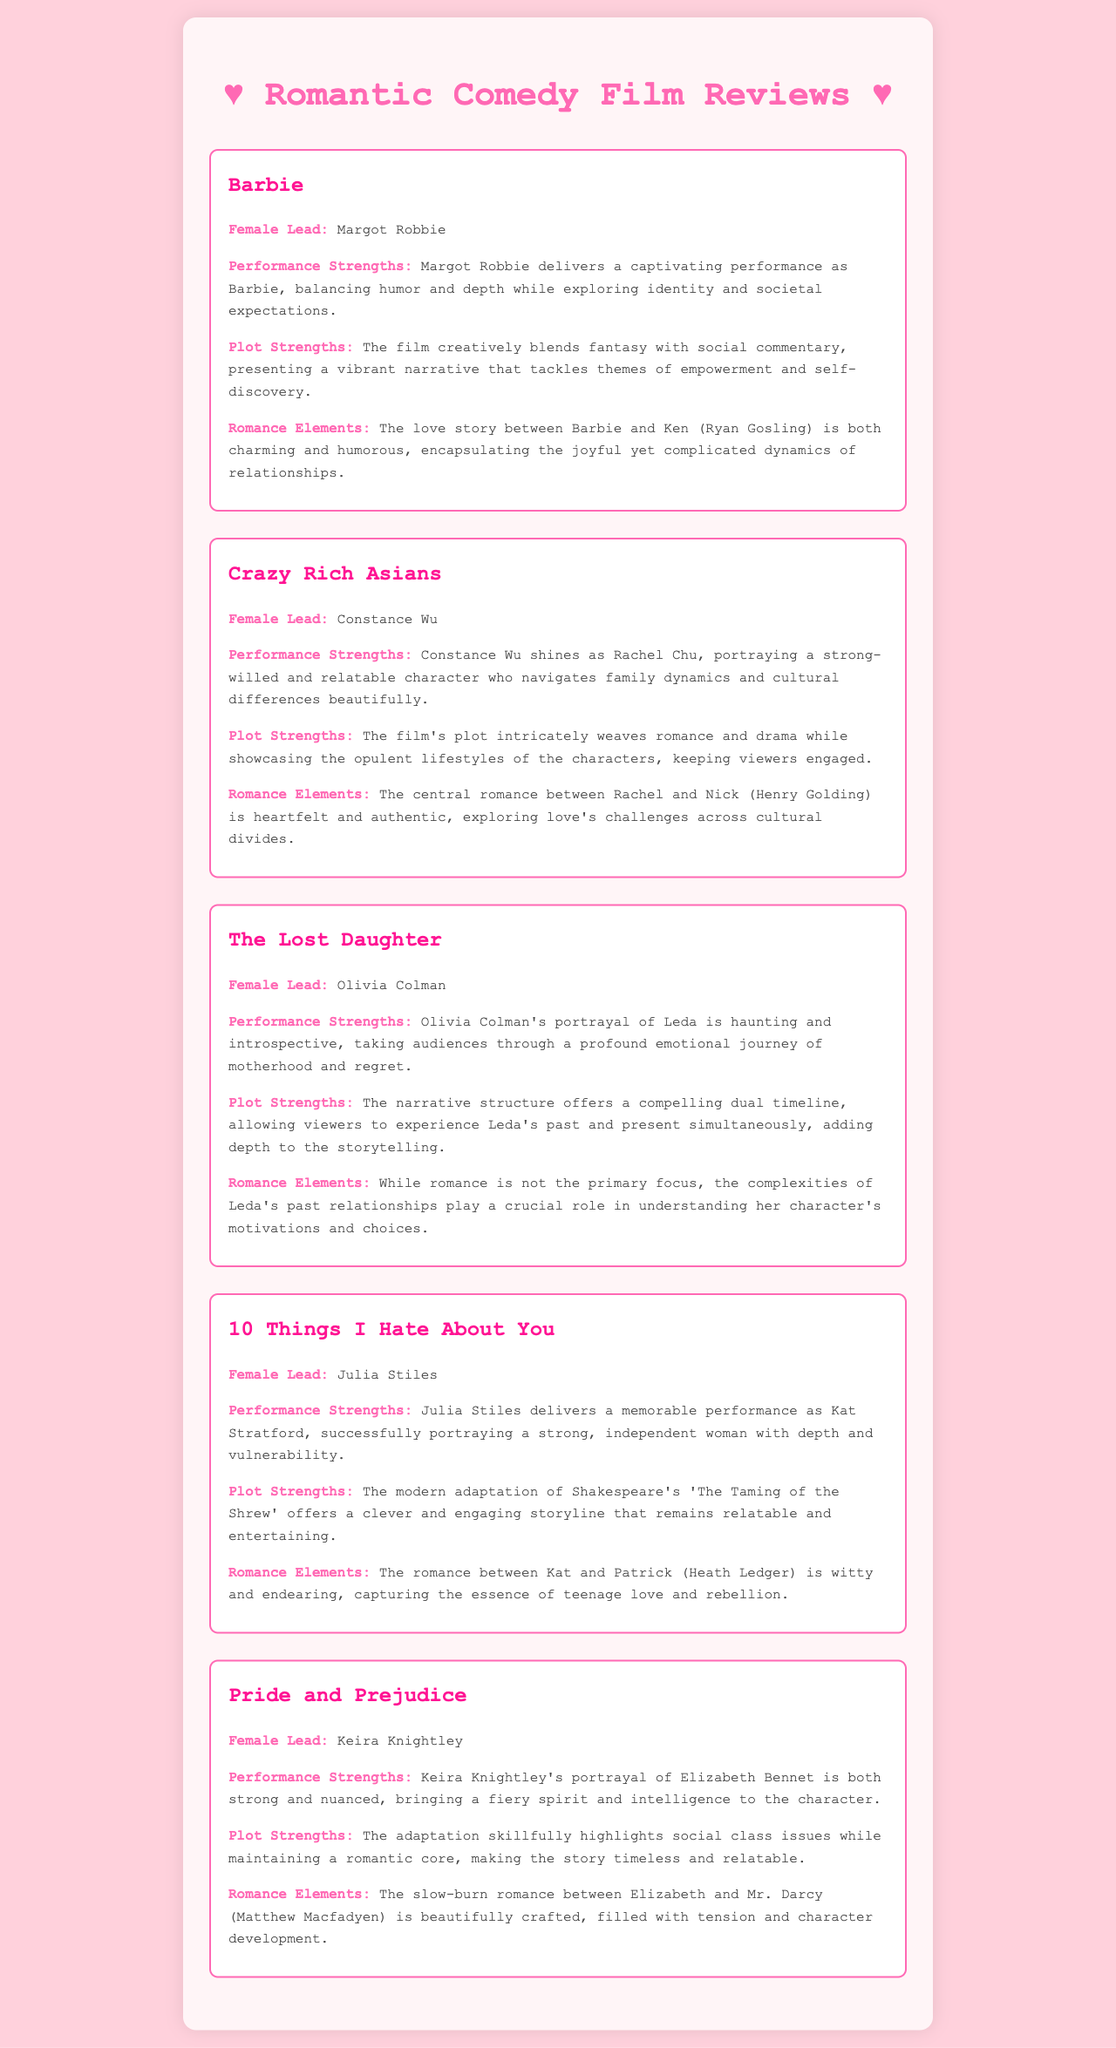what is the female lead in Barbie? The female lead in Barbie is Margot Robbie.
Answer: Margot Robbie who portrays Rachel Chu in Crazy Rich Asians? Rachel Chu is portrayed by Constance Wu.
Answer: Constance Wu what is a notable performance strength of Olivia Colman in The Lost Daughter? Olivia Colman's notable performance strength is her haunting and introspective portrayal of Leda.
Answer: haunting and introspective how does the romance between Kat and Patrick in 10 Things I Hate About You characterize teenage love? The romance is characterized as witty and endearing, capturing the essence of teenage love and rebellion.
Answer: witty and endearing what theme does the plot of Pride and Prejudice skillfully highlight? The plot skillfully highlights social class issues.
Answer: social class issues what is the central theme explored in Barbie? The central theme explored in Barbie is empowerment and self-discovery.
Answer: empowerment and self-discovery which character delivers a captivating performance in Crazy Rich Asians? Constance Wu's character delivers a captivating performance.
Answer: Rachel Chu how does the romance in The Lost Daughter impact Leda's character? The complexities of Leda's past relationships play a crucial role in understanding her character's motivations and choices.
Answer: complexities of Leda's past relationships what is the adaptation source for 10 Things I Hate About You? The adaptation source is Shakespeare's 'The Taming of the Shrew'.
Answer: 'The Taming of the Shrew' 